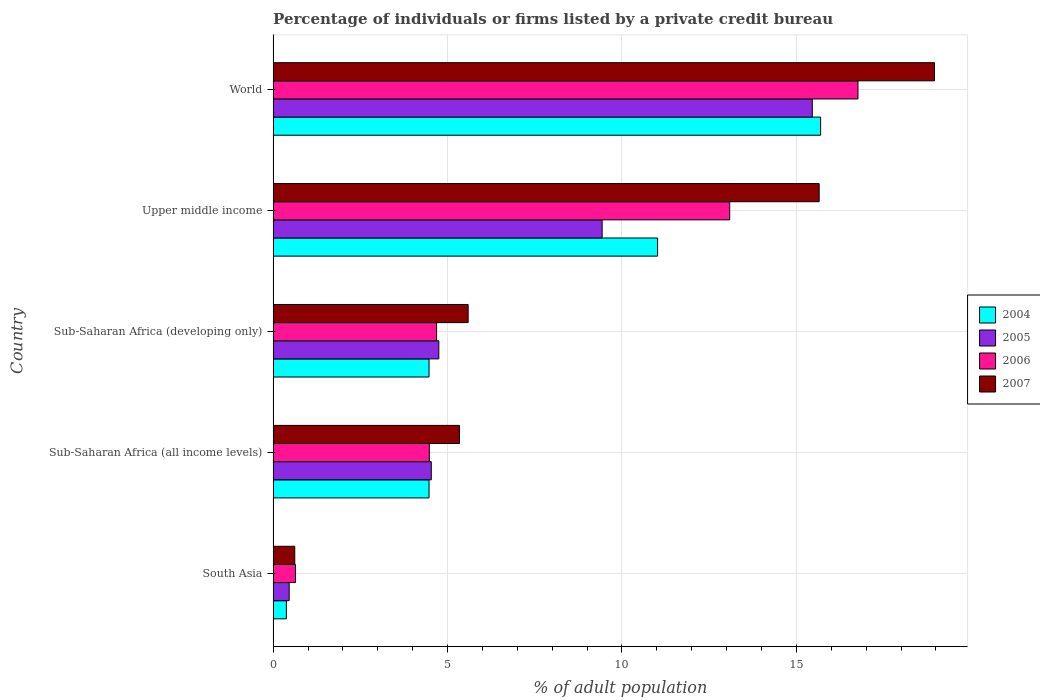How many different coloured bars are there?
Provide a short and direct response. 4. What is the label of the 2nd group of bars from the top?
Provide a short and direct response. Upper middle income. In how many cases, is the number of bars for a given country not equal to the number of legend labels?
Provide a succinct answer. 0. What is the percentage of population listed by a private credit bureau in 2007 in South Asia?
Offer a terse response. 0.62. Across all countries, what is the maximum percentage of population listed by a private credit bureau in 2006?
Your response must be concise. 16.77. Across all countries, what is the minimum percentage of population listed by a private credit bureau in 2005?
Your answer should be very brief. 0.46. In which country was the percentage of population listed by a private credit bureau in 2004 maximum?
Provide a short and direct response. World. In which country was the percentage of population listed by a private credit bureau in 2005 minimum?
Offer a terse response. South Asia. What is the total percentage of population listed by a private credit bureau in 2005 in the graph?
Offer a very short reply. 34.63. What is the difference between the percentage of population listed by a private credit bureau in 2005 in Sub-Saharan Africa (all income levels) and that in Upper middle income?
Your answer should be compact. -4.9. What is the difference between the percentage of population listed by a private credit bureau in 2004 in South Asia and the percentage of population listed by a private credit bureau in 2006 in Sub-Saharan Africa (developing only)?
Make the answer very short. -4.31. What is the average percentage of population listed by a private credit bureau in 2007 per country?
Ensure brevity in your answer.  9.23. What is the difference between the percentage of population listed by a private credit bureau in 2004 and percentage of population listed by a private credit bureau in 2006 in Sub-Saharan Africa (all income levels)?
Offer a terse response. -0.01. What is the ratio of the percentage of population listed by a private credit bureau in 2006 in South Asia to that in Sub-Saharan Africa (all income levels)?
Ensure brevity in your answer.  0.14. Is the percentage of population listed by a private credit bureau in 2004 in South Asia less than that in Upper middle income?
Provide a short and direct response. Yes. What is the difference between the highest and the second highest percentage of population listed by a private credit bureau in 2005?
Your answer should be very brief. 6.02. What is the difference between the highest and the lowest percentage of population listed by a private credit bureau in 2006?
Offer a very short reply. 16.13. Is the sum of the percentage of population listed by a private credit bureau in 2004 in Sub-Saharan Africa (all income levels) and Sub-Saharan Africa (developing only) greater than the maximum percentage of population listed by a private credit bureau in 2005 across all countries?
Your response must be concise. No. Is it the case that in every country, the sum of the percentage of population listed by a private credit bureau in 2007 and percentage of population listed by a private credit bureau in 2006 is greater than the sum of percentage of population listed by a private credit bureau in 2005 and percentage of population listed by a private credit bureau in 2004?
Provide a succinct answer. No. What does the 3rd bar from the top in South Asia represents?
Provide a succinct answer. 2005. Are all the bars in the graph horizontal?
Your answer should be very brief. Yes. How many countries are there in the graph?
Provide a succinct answer. 5. Are the values on the major ticks of X-axis written in scientific E-notation?
Keep it short and to the point. No. Where does the legend appear in the graph?
Give a very brief answer. Center right. How many legend labels are there?
Your answer should be very brief. 4. How are the legend labels stacked?
Give a very brief answer. Vertical. What is the title of the graph?
Give a very brief answer. Percentage of individuals or firms listed by a private credit bureau. What is the label or title of the X-axis?
Offer a very short reply. % of adult population. What is the label or title of the Y-axis?
Provide a short and direct response. Country. What is the % of adult population of 2004 in South Asia?
Offer a very short reply. 0.38. What is the % of adult population in 2005 in South Asia?
Provide a short and direct response. 0.46. What is the % of adult population in 2006 in South Asia?
Your response must be concise. 0.64. What is the % of adult population in 2007 in South Asia?
Offer a terse response. 0.62. What is the % of adult population in 2004 in Sub-Saharan Africa (all income levels)?
Your answer should be very brief. 4.47. What is the % of adult population of 2005 in Sub-Saharan Africa (all income levels)?
Your response must be concise. 4.53. What is the % of adult population in 2006 in Sub-Saharan Africa (all income levels)?
Ensure brevity in your answer.  4.48. What is the % of adult population in 2007 in Sub-Saharan Africa (all income levels)?
Keep it short and to the point. 5.34. What is the % of adult population in 2004 in Sub-Saharan Africa (developing only)?
Your answer should be very brief. 4.47. What is the % of adult population of 2005 in Sub-Saharan Africa (developing only)?
Ensure brevity in your answer.  4.75. What is the % of adult population of 2006 in Sub-Saharan Africa (developing only)?
Offer a very short reply. 4.69. What is the % of adult population in 2007 in Sub-Saharan Africa (developing only)?
Ensure brevity in your answer.  5.59. What is the % of adult population of 2004 in Upper middle income?
Give a very brief answer. 11.02. What is the % of adult population in 2005 in Upper middle income?
Provide a succinct answer. 9.43. What is the % of adult population in 2006 in Upper middle income?
Your response must be concise. 13.09. What is the % of adult population of 2007 in Upper middle income?
Your answer should be very brief. 15.65. What is the % of adult population in 2004 in World?
Offer a very short reply. 15.7. What is the % of adult population of 2005 in World?
Keep it short and to the point. 15.46. What is the % of adult population in 2006 in World?
Your answer should be very brief. 16.77. What is the % of adult population in 2007 in World?
Your answer should be very brief. 18.96. Across all countries, what is the maximum % of adult population of 2004?
Your answer should be compact. 15.7. Across all countries, what is the maximum % of adult population in 2005?
Keep it short and to the point. 15.46. Across all countries, what is the maximum % of adult population in 2006?
Your response must be concise. 16.77. Across all countries, what is the maximum % of adult population in 2007?
Provide a short and direct response. 18.96. Across all countries, what is the minimum % of adult population of 2004?
Give a very brief answer. 0.38. Across all countries, what is the minimum % of adult population of 2005?
Ensure brevity in your answer.  0.46. Across all countries, what is the minimum % of adult population of 2006?
Make the answer very short. 0.64. Across all countries, what is the minimum % of adult population in 2007?
Make the answer very short. 0.62. What is the total % of adult population in 2004 in the graph?
Your answer should be very brief. 36.04. What is the total % of adult population of 2005 in the graph?
Provide a succinct answer. 34.63. What is the total % of adult population in 2006 in the graph?
Offer a very short reply. 39.66. What is the total % of adult population in 2007 in the graph?
Your response must be concise. 46.17. What is the difference between the % of adult population of 2004 in South Asia and that in Sub-Saharan Africa (all income levels)?
Make the answer very short. -4.09. What is the difference between the % of adult population of 2005 in South Asia and that in Sub-Saharan Africa (all income levels)?
Offer a terse response. -4.07. What is the difference between the % of adult population in 2006 in South Asia and that in Sub-Saharan Africa (all income levels)?
Offer a very short reply. -3.84. What is the difference between the % of adult population of 2007 in South Asia and that in Sub-Saharan Africa (all income levels)?
Give a very brief answer. -4.72. What is the difference between the % of adult population of 2004 in South Asia and that in Sub-Saharan Africa (developing only)?
Your answer should be compact. -4.09. What is the difference between the % of adult population of 2005 in South Asia and that in Sub-Saharan Africa (developing only)?
Your answer should be compact. -4.29. What is the difference between the % of adult population in 2006 in South Asia and that in Sub-Saharan Africa (developing only)?
Provide a short and direct response. -4.05. What is the difference between the % of adult population in 2007 in South Asia and that in Sub-Saharan Africa (developing only)?
Offer a very short reply. -4.97. What is the difference between the % of adult population of 2004 in South Asia and that in Upper middle income?
Ensure brevity in your answer.  -10.64. What is the difference between the % of adult population of 2005 in South Asia and that in Upper middle income?
Provide a succinct answer. -8.97. What is the difference between the % of adult population of 2006 in South Asia and that in Upper middle income?
Offer a very short reply. -12.45. What is the difference between the % of adult population in 2007 in South Asia and that in Upper middle income?
Make the answer very short. -15.03. What is the difference between the % of adult population of 2004 in South Asia and that in World?
Your answer should be compact. -15.32. What is the difference between the % of adult population of 2005 in South Asia and that in World?
Offer a very short reply. -15. What is the difference between the % of adult population of 2006 in South Asia and that in World?
Ensure brevity in your answer.  -16.13. What is the difference between the % of adult population in 2007 in South Asia and that in World?
Provide a short and direct response. -18.34. What is the difference between the % of adult population in 2005 in Sub-Saharan Africa (all income levels) and that in Sub-Saharan Africa (developing only)?
Offer a terse response. -0.22. What is the difference between the % of adult population of 2006 in Sub-Saharan Africa (all income levels) and that in Sub-Saharan Africa (developing only)?
Your response must be concise. -0.21. What is the difference between the % of adult population in 2007 in Sub-Saharan Africa (all income levels) and that in Sub-Saharan Africa (developing only)?
Give a very brief answer. -0.25. What is the difference between the % of adult population in 2004 in Sub-Saharan Africa (all income levels) and that in Upper middle income?
Your answer should be very brief. -6.55. What is the difference between the % of adult population of 2005 in Sub-Saharan Africa (all income levels) and that in Upper middle income?
Offer a very short reply. -4.9. What is the difference between the % of adult population in 2006 in Sub-Saharan Africa (all income levels) and that in Upper middle income?
Provide a succinct answer. -8.61. What is the difference between the % of adult population in 2007 in Sub-Saharan Africa (all income levels) and that in Upper middle income?
Keep it short and to the point. -10.31. What is the difference between the % of adult population of 2004 in Sub-Saharan Africa (all income levels) and that in World?
Give a very brief answer. -11.23. What is the difference between the % of adult population in 2005 in Sub-Saharan Africa (all income levels) and that in World?
Keep it short and to the point. -10.92. What is the difference between the % of adult population of 2006 in Sub-Saharan Africa (all income levels) and that in World?
Your answer should be very brief. -12.29. What is the difference between the % of adult population of 2007 in Sub-Saharan Africa (all income levels) and that in World?
Offer a very short reply. -13.62. What is the difference between the % of adult population of 2004 in Sub-Saharan Africa (developing only) and that in Upper middle income?
Provide a short and direct response. -6.55. What is the difference between the % of adult population of 2005 in Sub-Saharan Africa (developing only) and that in Upper middle income?
Provide a succinct answer. -4.68. What is the difference between the % of adult population in 2006 in Sub-Saharan Africa (developing only) and that in Upper middle income?
Your response must be concise. -8.4. What is the difference between the % of adult population of 2007 in Sub-Saharan Africa (developing only) and that in Upper middle income?
Give a very brief answer. -10.06. What is the difference between the % of adult population in 2004 in Sub-Saharan Africa (developing only) and that in World?
Your answer should be very brief. -11.23. What is the difference between the % of adult population of 2005 in Sub-Saharan Africa (developing only) and that in World?
Your answer should be compact. -10.71. What is the difference between the % of adult population in 2006 in Sub-Saharan Africa (developing only) and that in World?
Ensure brevity in your answer.  -12.08. What is the difference between the % of adult population of 2007 in Sub-Saharan Africa (developing only) and that in World?
Make the answer very short. -13.37. What is the difference between the % of adult population of 2004 in Upper middle income and that in World?
Give a very brief answer. -4.67. What is the difference between the % of adult population of 2005 in Upper middle income and that in World?
Offer a terse response. -6.02. What is the difference between the % of adult population in 2006 in Upper middle income and that in World?
Offer a terse response. -3.68. What is the difference between the % of adult population in 2007 in Upper middle income and that in World?
Provide a short and direct response. -3.31. What is the difference between the % of adult population in 2004 in South Asia and the % of adult population in 2005 in Sub-Saharan Africa (all income levels)?
Offer a terse response. -4.15. What is the difference between the % of adult population in 2004 in South Asia and the % of adult population in 2006 in Sub-Saharan Africa (all income levels)?
Your answer should be compact. -4.1. What is the difference between the % of adult population of 2004 in South Asia and the % of adult population of 2007 in Sub-Saharan Africa (all income levels)?
Provide a short and direct response. -4.96. What is the difference between the % of adult population of 2005 in South Asia and the % of adult population of 2006 in Sub-Saharan Africa (all income levels)?
Keep it short and to the point. -4.02. What is the difference between the % of adult population of 2005 in South Asia and the % of adult population of 2007 in Sub-Saharan Africa (all income levels)?
Give a very brief answer. -4.88. What is the difference between the % of adult population of 2006 in South Asia and the % of adult population of 2007 in Sub-Saharan Africa (all income levels)?
Your response must be concise. -4.7. What is the difference between the % of adult population in 2004 in South Asia and the % of adult population in 2005 in Sub-Saharan Africa (developing only)?
Make the answer very short. -4.37. What is the difference between the % of adult population in 2004 in South Asia and the % of adult population in 2006 in Sub-Saharan Africa (developing only)?
Keep it short and to the point. -4.31. What is the difference between the % of adult population of 2004 in South Asia and the % of adult population of 2007 in Sub-Saharan Africa (developing only)?
Offer a very short reply. -5.21. What is the difference between the % of adult population of 2005 in South Asia and the % of adult population of 2006 in Sub-Saharan Africa (developing only)?
Give a very brief answer. -4.23. What is the difference between the % of adult population of 2005 in South Asia and the % of adult population of 2007 in Sub-Saharan Africa (developing only)?
Offer a terse response. -5.13. What is the difference between the % of adult population of 2006 in South Asia and the % of adult population of 2007 in Sub-Saharan Africa (developing only)?
Provide a short and direct response. -4.95. What is the difference between the % of adult population of 2004 in South Asia and the % of adult population of 2005 in Upper middle income?
Your answer should be compact. -9.05. What is the difference between the % of adult population of 2004 in South Asia and the % of adult population of 2006 in Upper middle income?
Make the answer very short. -12.71. What is the difference between the % of adult population of 2004 in South Asia and the % of adult population of 2007 in Upper middle income?
Ensure brevity in your answer.  -15.27. What is the difference between the % of adult population in 2005 in South Asia and the % of adult population in 2006 in Upper middle income?
Keep it short and to the point. -12.63. What is the difference between the % of adult population of 2005 in South Asia and the % of adult population of 2007 in Upper middle income?
Give a very brief answer. -15.19. What is the difference between the % of adult population in 2006 in South Asia and the % of adult population in 2007 in Upper middle income?
Provide a short and direct response. -15.01. What is the difference between the % of adult population in 2004 in South Asia and the % of adult population in 2005 in World?
Your answer should be very brief. -15.08. What is the difference between the % of adult population in 2004 in South Asia and the % of adult population in 2006 in World?
Give a very brief answer. -16.39. What is the difference between the % of adult population of 2004 in South Asia and the % of adult population of 2007 in World?
Give a very brief answer. -18.58. What is the difference between the % of adult population of 2005 in South Asia and the % of adult population of 2006 in World?
Provide a succinct answer. -16.31. What is the difference between the % of adult population in 2005 in South Asia and the % of adult population in 2007 in World?
Provide a succinct answer. -18.5. What is the difference between the % of adult population of 2006 in South Asia and the % of adult population of 2007 in World?
Give a very brief answer. -18.32. What is the difference between the % of adult population of 2004 in Sub-Saharan Africa (all income levels) and the % of adult population of 2005 in Sub-Saharan Africa (developing only)?
Give a very brief answer. -0.28. What is the difference between the % of adult population of 2004 in Sub-Saharan Africa (all income levels) and the % of adult population of 2006 in Sub-Saharan Africa (developing only)?
Keep it short and to the point. -0.22. What is the difference between the % of adult population of 2004 in Sub-Saharan Africa (all income levels) and the % of adult population of 2007 in Sub-Saharan Africa (developing only)?
Provide a succinct answer. -1.12. What is the difference between the % of adult population of 2005 in Sub-Saharan Africa (all income levels) and the % of adult population of 2006 in Sub-Saharan Africa (developing only)?
Make the answer very short. -0.15. What is the difference between the % of adult population of 2005 in Sub-Saharan Africa (all income levels) and the % of adult population of 2007 in Sub-Saharan Africa (developing only)?
Offer a terse response. -1.06. What is the difference between the % of adult population in 2006 in Sub-Saharan Africa (all income levels) and the % of adult population in 2007 in Sub-Saharan Africa (developing only)?
Offer a very short reply. -1.11. What is the difference between the % of adult population of 2004 in Sub-Saharan Africa (all income levels) and the % of adult population of 2005 in Upper middle income?
Make the answer very short. -4.96. What is the difference between the % of adult population of 2004 in Sub-Saharan Africa (all income levels) and the % of adult population of 2006 in Upper middle income?
Make the answer very short. -8.62. What is the difference between the % of adult population of 2004 in Sub-Saharan Africa (all income levels) and the % of adult population of 2007 in Upper middle income?
Make the answer very short. -11.18. What is the difference between the % of adult population of 2005 in Sub-Saharan Africa (all income levels) and the % of adult population of 2006 in Upper middle income?
Your answer should be compact. -8.55. What is the difference between the % of adult population of 2005 in Sub-Saharan Africa (all income levels) and the % of adult population of 2007 in Upper middle income?
Ensure brevity in your answer.  -11.12. What is the difference between the % of adult population in 2006 in Sub-Saharan Africa (all income levels) and the % of adult population in 2007 in Upper middle income?
Ensure brevity in your answer.  -11.18. What is the difference between the % of adult population of 2004 in Sub-Saharan Africa (all income levels) and the % of adult population of 2005 in World?
Your answer should be very brief. -10.99. What is the difference between the % of adult population of 2004 in Sub-Saharan Africa (all income levels) and the % of adult population of 2006 in World?
Provide a short and direct response. -12.3. What is the difference between the % of adult population in 2004 in Sub-Saharan Africa (all income levels) and the % of adult population in 2007 in World?
Make the answer very short. -14.49. What is the difference between the % of adult population in 2005 in Sub-Saharan Africa (all income levels) and the % of adult population in 2006 in World?
Your response must be concise. -12.23. What is the difference between the % of adult population in 2005 in Sub-Saharan Africa (all income levels) and the % of adult population in 2007 in World?
Keep it short and to the point. -14.43. What is the difference between the % of adult population in 2006 in Sub-Saharan Africa (all income levels) and the % of adult population in 2007 in World?
Provide a succinct answer. -14.48. What is the difference between the % of adult population of 2004 in Sub-Saharan Africa (developing only) and the % of adult population of 2005 in Upper middle income?
Give a very brief answer. -4.96. What is the difference between the % of adult population in 2004 in Sub-Saharan Africa (developing only) and the % of adult population in 2006 in Upper middle income?
Your response must be concise. -8.62. What is the difference between the % of adult population in 2004 in Sub-Saharan Africa (developing only) and the % of adult population in 2007 in Upper middle income?
Provide a short and direct response. -11.18. What is the difference between the % of adult population in 2005 in Sub-Saharan Africa (developing only) and the % of adult population in 2006 in Upper middle income?
Offer a terse response. -8.34. What is the difference between the % of adult population of 2005 in Sub-Saharan Africa (developing only) and the % of adult population of 2007 in Upper middle income?
Offer a terse response. -10.9. What is the difference between the % of adult population in 2006 in Sub-Saharan Africa (developing only) and the % of adult population in 2007 in Upper middle income?
Give a very brief answer. -10.97. What is the difference between the % of adult population in 2004 in Sub-Saharan Africa (developing only) and the % of adult population in 2005 in World?
Your answer should be compact. -10.99. What is the difference between the % of adult population in 2004 in Sub-Saharan Africa (developing only) and the % of adult population in 2006 in World?
Offer a terse response. -12.3. What is the difference between the % of adult population of 2004 in Sub-Saharan Africa (developing only) and the % of adult population of 2007 in World?
Offer a very short reply. -14.49. What is the difference between the % of adult population of 2005 in Sub-Saharan Africa (developing only) and the % of adult population of 2006 in World?
Make the answer very short. -12.02. What is the difference between the % of adult population of 2005 in Sub-Saharan Africa (developing only) and the % of adult population of 2007 in World?
Give a very brief answer. -14.21. What is the difference between the % of adult population of 2006 in Sub-Saharan Africa (developing only) and the % of adult population of 2007 in World?
Provide a short and direct response. -14.27. What is the difference between the % of adult population in 2004 in Upper middle income and the % of adult population in 2005 in World?
Provide a succinct answer. -4.43. What is the difference between the % of adult population in 2004 in Upper middle income and the % of adult population in 2006 in World?
Provide a short and direct response. -5.74. What is the difference between the % of adult population in 2004 in Upper middle income and the % of adult population in 2007 in World?
Keep it short and to the point. -7.94. What is the difference between the % of adult population in 2005 in Upper middle income and the % of adult population in 2006 in World?
Offer a very short reply. -7.33. What is the difference between the % of adult population in 2005 in Upper middle income and the % of adult population in 2007 in World?
Offer a very short reply. -9.53. What is the difference between the % of adult population of 2006 in Upper middle income and the % of adult population of 2007 in World?
Provide a short and direct response. -5.87. What is the average % of adult population of 2004 per country?
Give a very brief answer. 7.21. What is the average % of adult population in 2005 per country?
Provide a succinct answer. 6.93. What is the average % of adult population of 2006 per country?
Give a very brief answer. 7.93. What is the average % of adult population of 2007 per country?
Provide a short and direct response. 9.23. What is the difference between the % of adult population of 2004 and % of adult population of 2005 in South Asia?
Your answer should be compact. -0.08. What is the difference between the % of adult population in 2004 and % of adult population in 2006 in South Asia?
Your answer should be compact. -0.26. What is the difference between the % of adult population of 2004 and % of adult population of 2007 in South Asia?
Provide a short and direct response. -0.24. What is the difference between the % of adult population of 2005 and % of adult population of 2006 in South Asia?
Your response must be concise. -0.18. What is the difference between the % of adult population in 2005 and % of adult population in 2007 in South Asia?
Provide a succinct answer. -0.16. What is the difference between the % of adult population in 2004 and % of adult population in 2005 in Sub-Saharan Africa (all income levels)?
Your answer should be very brief. -0.06. What is the difference between the % of adult population of 2004 and % of adult population of 2006 in Sub-Saharan Africa (all income levels)?
Keep it short and to the point. -0.01. What is the difference between the % of adult population of 2004 and % of adult population of 2007 in Sub-Saharan Africa (all income levels)?
Provide a succinct answer. -0.87. What is the difference between the % of adult population in 2005 and % of adult population in 2006 in Sub-Saharan Africa (all income levels)?
Make the answer very short. 0.06. What is the difference between the % of adult population of 2005 and % of adult population of 2007 in Sub-Saharan Africa (all income levels)?
Your response must be concise. -0.81. What is the difference between the % of adult population in 2006 and % of adult population in 2007 in Sub-Saharan Africa (all income levels)?
Make the answer very short. -0.86. What is the difference between the % of adult population in 2004 and % of adult population in 2005 in Sub-Saharan Africa (developing only)?
Your response must be concise. -0.28. What is the difference between the % of adult population of 2004 and % of adult population of 2006 in Sub-Saharan Africa (developing only)?
Provide a succinct answer. -0.22. What is the difference between the % of adult population in 2004 and % of adult population in 2007 in Sub-Saharan Africa (developing only)?
Provide a short and direct response. -1.12. What is the difference between the % of adult population in 2005 and % of adult population in 2006 in Sub-Saharan Africa (developing only)?
Keep it short and to the point. 0.06. What is the difference between the % of adult population in 2005 and % of adult population in 2007 in Sub-Saharan Africa (developing only)?
Make the answer very short. -0.84. What is the difference between the % of adult population in 2006 and % of adult population in 2007 in Sub-Saharan Africa (developing only)?
Provide a short and direct response. -0.9. What is the difference between the % of adult population in 2004 and % of adult population in 2005 in Upper middle income?
Provide a succinct answer. 1.59. What is the difference between the % of adult population of 2004 and % of adult population of 2006 in Upper middle income?
Keep it short and to the point. -2.07. What is the difference between the % of adult population of 2004 and % of adult population of 2007 in Upper middle income?
Provide a short and direct response. -4.63. What is the difference between the % of adult population in 2005 and % of adult population in 2006 in Upper middle income?
Your answer should be very brief. -3.66. What is the difference between the % of adult population of 2005 and % of adult population of 2007 in Upper middle income?
Keep it short and to the point. -6.22. What is the difference between the % of adult population in 2006 and % of adult population in 2007 in Upper middle income?
Keep it short and to the point. -2.56. What is the difference between the % of adult population in 2004 and % of adult population in 2005 in World?
Provide a succinct answer. 0.24. What is the difference between the % of adult population in 2004 and % of adult population in 2006 in World?
Give a very brief answer. -1.07. What is the difference between the % of adult population of 2004 and % of adult population of 2007 in World?
Provide a succinct answer. -3.26. What is the difference between the % of adult population of 2005 and % of adult population of 2006 in World?
Give a very brief answer. -1.31. What is the difference between the % of adult population in 2005 and % of adult population in 2007 in World?
Keep it short and to the point. -3.5. What is the difference between the % of adult population in 2006 and % of adult population in 2007 in World?
Offer a terse response. -2.19. What is the ratio of the % of adult population in 2004 in South Asia to that in Sub-Saharan Africa (all income levels)?
Ensure brevity in your answer.  0.09. What is the ratio of the % of adult population of 2005 in South Asia to that in Sub-Saharan Africa (all income levels)?
Keep it short and to the point. 0.1. What is the ratio of the % of adult population in 2006 in South Asia to that in Sub-Saharan Africa (all income levels)?
Ensure brevity in your answer.  0.14. What is the ratio of the % of adult population of 2007 in South Asia to that in Sub-Saharan Africa (all income levels)?
Your answer should be compact. 0.12. What is the ratio of the % of adult population in 2004 in South Asia to that in Sub-Saharan Africa (developing only)?
Ensure brevity in your answer.  0.09. What is the ratio of the % of adult population in 2005 in South Asia to that in Sub-Saharan Africa (developing only)?
Keep it short and to the point. 0.1. What is the ratio of the % of adult population in 2006 in South Asia to that in Sub-Saharan Africa (developing only)?
Offer a very short reply. 0.14. What is the ratio of the % of adult population of 2007 in South Asia to that in Sub-Saharan Africa (developing only)?
Your answer should be compact. 0.11. What is the ratio of the % of adult population in 2004 in South Asia to that in Upper middle income?
Provide a succinct answer. 0.03. What is the ratio of the % of adult population of 2005 in South Asia to that in Upper middle income?
Ensure brevity in your answer.  0.05. What is the ratio of the % of adult population of 2006 in South Asia to that in Upper middle income?
Provide a succinct answer. 0.05. What is the ratio of the % of adult population of 2007 in South Asia to that in Upper middle income?
Offer a terse response. 0.04. What is the ratio of the % of adult population in 2004 in South Asia to that in World?
Give a very brief answer. 0.02. What is the ratio of the % of adult population of 2005 in South Asia to that in World?
Ensure brevity in your answer.  0.03. What is the ratio of the % of adult population of 2006 in South Asia to that in World?
Offer a very short reply. 0.04. What is the ratio of the % of adult population in 2007 in South Asia to that in World?
Ensure brevity in your answer.  0.03. What is the ratio of the % of adult population of 2004 in Sub-Saharan Africa (all income levels) to that in Sub-Saharan Africa (developing only)?
Give a very brief answer. 1. What is the ratio of the % of adult population of 2005 in Sub-Saharan Africa (all income levels) to that in Sub-Saharan Africa (developing only)?
Your answer should be very brief. 0.95. What is the ratio of the % of adult population in 2006 in Sub-Saharan Africa (all income levels) to that in Sub-Saharan Africa (developing only)?
Offer a very short reply. 0.96. What is the ratio of the % of adult population of 2007 in Sub-Saharan Africa (all income levels) to that in Sub-Saharan Africa (developing only)?
Offer a very short reply. 0.96. What is the ratio of the % of adult population of 2004 in Sub-Saharan Africa (all income levels) to that in Upper middle income?
Keep it short and to the point. 0.41. What is the ratio of the % of adult population of 2005 in Sub-Saharan Africa (all income levels) to that in Upper middle income?
Your answer should be very brief. 0.48. What is the ratio of the % of adult population of 2006 in Sub-Saharan Africa (all income levels) to that in Upper middle income?
Your answer should be compact. 0.34. What is the ratio of the % of adult population in 2007 in Sub-Saharan Africa (all income levels) to that in Upper middle income?
Give a very brief answer. 0.34. What is the ratio of the % of adult population of 2004 in Sub-Saharan Africa (all income levels) to that in World?
Your answer should be very brief. 0.28. What is the ratio of the % of adult population in 2005 in Sub-Saharan Africa (all income levels) to that in World?
Provide a succinct answer. 0.29. What is the ratio of the % of adult population in 2006 in Sub-Saharan Africa (all income levels) to that in World?
Your answer should be very brief. 0.27. What is the ratio of the % of adult population of 2007 in Sub-Saharan Africa (all income levels) to that in World?
Offer a terse response. 0.28. What is the ratio of the % of adult population in 2004 in Sub-Saharan Africa (developing only) to that in Upper middle income?
Provide a succinct answer. 0.41. What is the ratio of the % of adult population of 2005 in Sub-Saharan Africa (developing only) to that in Upper middle income?
Your response must be concise. 0.5. What is the ratio of the % of adult population in 2006 in Sub-Saharan Africa (developing only) to that in Upper middle income?
Ensure brevity in your answer.  0.36. What is the ratio of the % of adult population in 2007 in Sub-Saharan Africa (developing only) to that in Upper middle income?
Provide a succinct answer. 0.36. What is the ratio of the % of adult population of 2004 in Sub-Saharan Africa (developing only) to that in World?
Offer a very short reply. 0.28. What is the ratio of the % of adult population in 2005 in Sub-Saharan Africa (developing only) to that in World?
Give a very brief answer. 0.31. What is the ratio of the % of adult population of 2006 in Sub-Saharan Africa (developing only) to that in World?
Offer a terse response. 0.28. What is the ratio of the % of adult population of 2007 in Sub-Saharan Africa (developing only) to that in World?
Keep it short and to the point. 0.29. What is the ratio of the % of adult population of 2004 in Upper middle income to that in World?
Ensure brevity in your answer.  0.7. What is the ratio of the % of adult population of 2005 in Upper middle income to that in World?
Keep it short and to the point. 0.61. What is the ratio of the % of adult population in 2006 in Upper middle income to that in World?
Make the answer very short. 0.78. What is the ratio of the % of adult population of 2007 in Upper middle income to that in World?
Give a very brief answer. 0.83. What is the difference between the highest and the second highest % of adult population of 2004?
Offer a very short reply. 4.67. What is the difference between the highest and the second highest % of adult population of 2005?
Your response must be concise. 6.02. What is the difference between the highest and the second highest % of adult population of 2006?
Ensure brevity in your answer.  3.68. What is the difference between the highest and the second highest % of adult population in 2007?
Offer a very short reply. 3.31. What is the difference between the highest and the lowest % of adult population of 2004?
Your response must be concise. 15.32. What is the difference between the highest and the lowest % of adult population of 2005?
Offer a terse response. 15. What is the difference between the highest and the lowest % of adult population in 2006?
Your answer should be very brief. 16.13. What is the difference between the highest and the lowest % of adult population in 2007?
Ensure brevity in your answer.  18.34. 